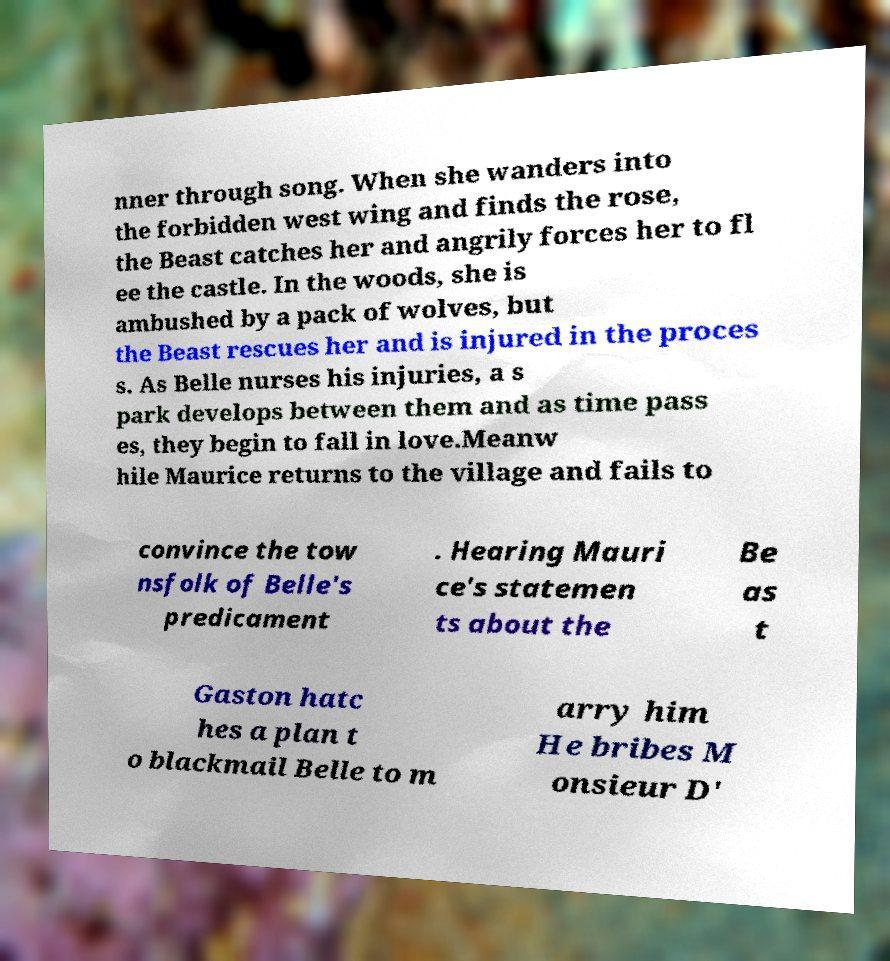There's text embedded in this image that I need extracted. Can you transcribe it verbatim? nner through song. When she wanders into the forbidden west wing and finds the rose, the Beast catches her and angrily forces her to fl ee the castle. In the woods, she is ambushed by a pack of wolves, but the Beast rescues her and is injured in the proces s. As Belle nurses his injuries, a s park develops between them and as time pass es, they begin to fall in love.Meanw hile Maurice returns to the village and fails to convince the tow nsfolk of Belle's predicament . Hearing Mauri ce's statemen ts about the Be as t Gaston hatc hes a plan t o blackmail Belle to m arry him He bribes M onsieur D' 